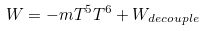<formula> <loc_0><loc_0><loc_500><loc_500>W = - m T ^ { 5 } T ^ { 6 } + W _ { d e c o u p l e }</formula> 